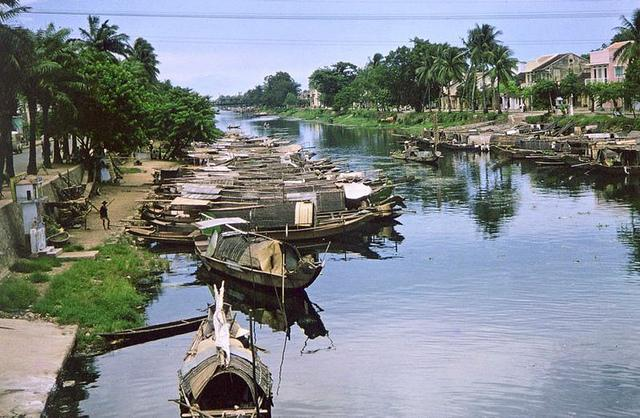What powers those boats?

Choices:
A) humans
B) steam
C) gas
D) propane humans 